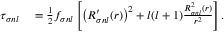Convert formula to latex. <formula><loc_0><loc_0><loc_500><loc_500>\begin{array} { r l } { \tau _ { \sigma n l } } & = \frac { 1 } { 2 } f _ { \sigma n l } \left [ \left ( R _ { \sigma n l } ^ { \prime } ( r ) \right ) ^ { 2 } + l ( l + 1 ) \frac { R _ { \sigma n l } ^ { 2 } ( r ) } { r ^ { 2 } } \right ] . } \end{array}</formula> 